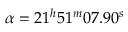Convert formula to latex. <formula><loc_0><loc_0><loc_500><loc_500>\alpha = 2 1 ^ { h } 5 1 ^ { m } 0 7 . 9 0 ^ { s }</formula> 